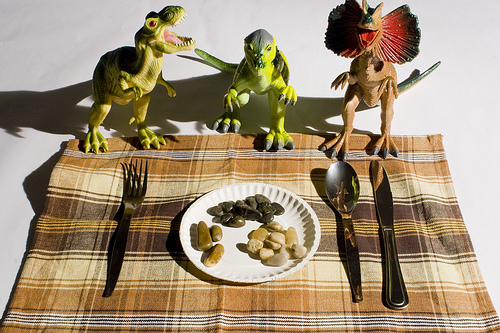<image>
Can you confirm if the dinosaur is above the rocks? No. The dinosaur is not positioned above the rocks. The vertical arrangement shows a different relationship. 